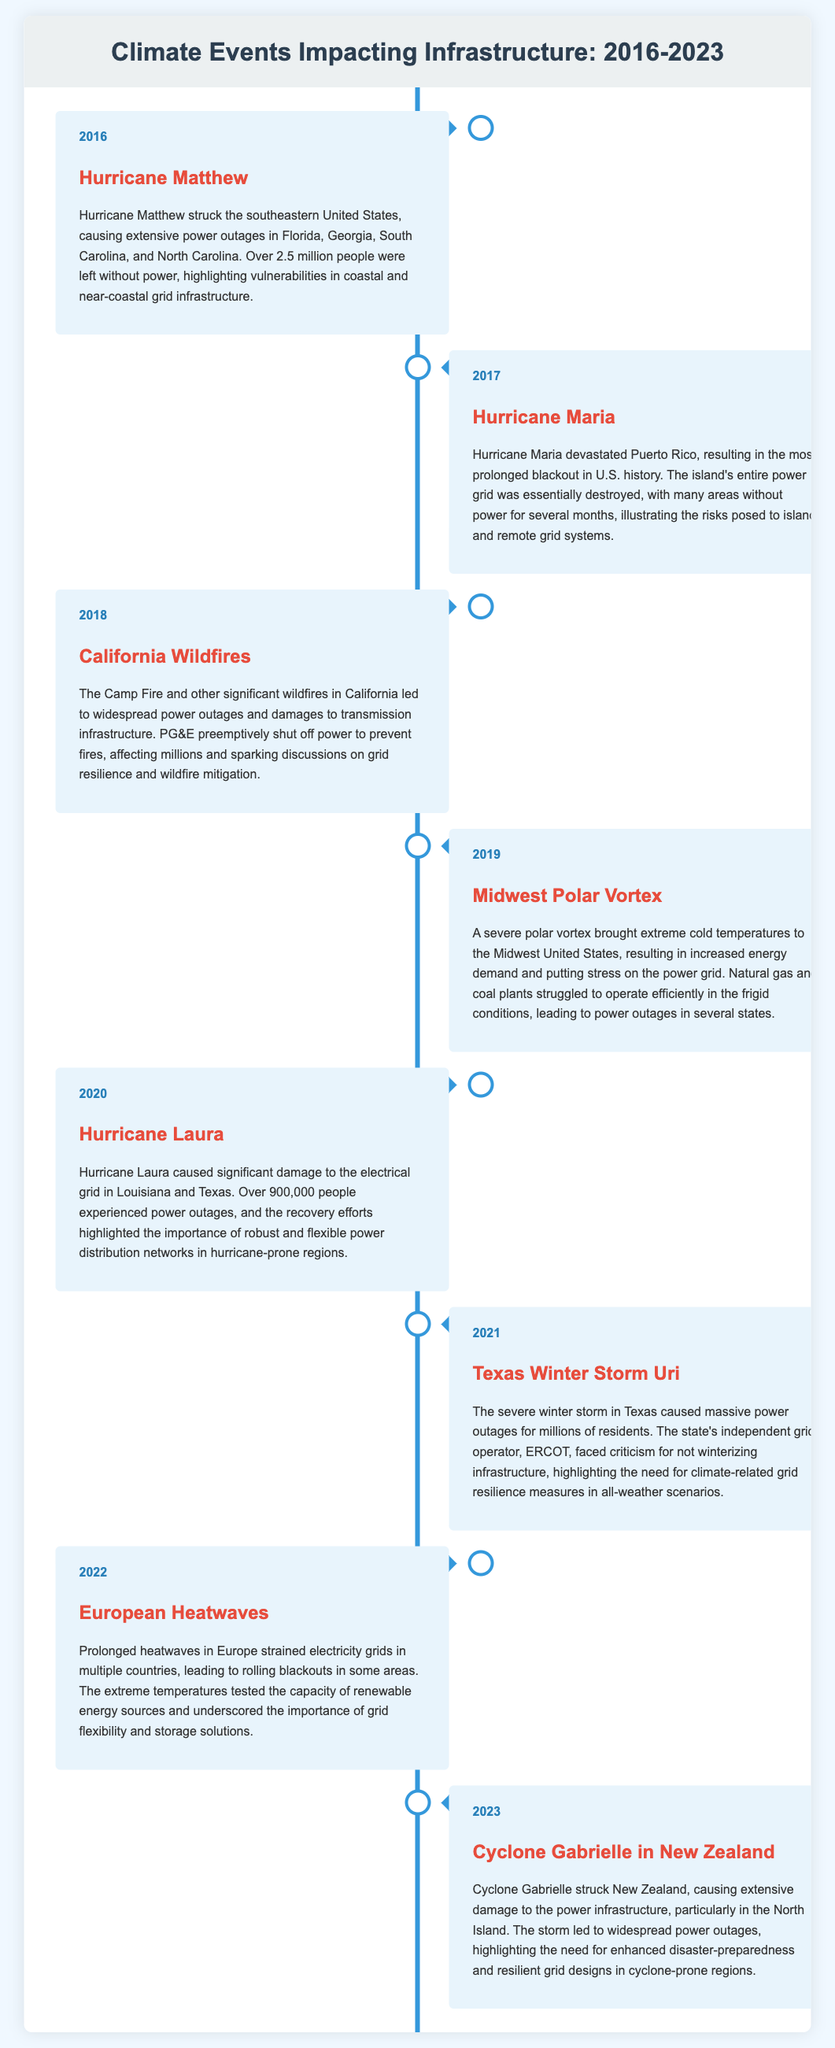What event caused over 2.5 million people to lose power? The event is Hurricane Matthew which struck the southeastern United States in 2016, leaving many regions without power.
Answer: Hurricane Matthew Which hurricane led to the most prolonged blackout in U.S. history? Hurricane Maria, which devastated Puerto Rico in 2017, caused the longest blackout, severely affecting its entire power grid.
Answer: Hurricane Maria What year did the California Wildfires cause preemptive power outages? The California Wildfires led to widespread power outages in the year 2018.
Answer: 2018 How many people experienced power outages due to Hurricane Laura? Over 900,000 people were affected by power outages caused by Hurricane Laura in 2020.
Answer: 900,000 Which event highlighted the need for winterization of infrastructure in Texas? The winter storm known as Texas Winter Storm Uri in 2021 brought massive power outages, showcasing the need for resilience against extreme weather.
Answer: Texas Winter Storm Uri What natural disaster impacted power supply in both Louisiana and Texas? Hurricane Laura in 2020 caused significant damage to the electrical grid in both Louisiana and Texas.
Answer: Hurricane Laura Which year saw prolonged heatwaves that led to rolling blackouts in Europe? Prolonged heatwaves affected the electricity grids in multiple countries across Europe in the year 2022.
Answer: 2022 Which cyclone struck New Zealand in 2023 causing power outages? Cyclone Gabrielle caused extensive damage to the power infrastructure in New Zealand in 2023.
Answer: Cyclone Gabrielle What were the implications of the Midwest Polar Vortex in 2019? The polar vortex led to increased energy demand and stress on the power grid in the Midwest.
Answer: Increased energy demand and grid stress 